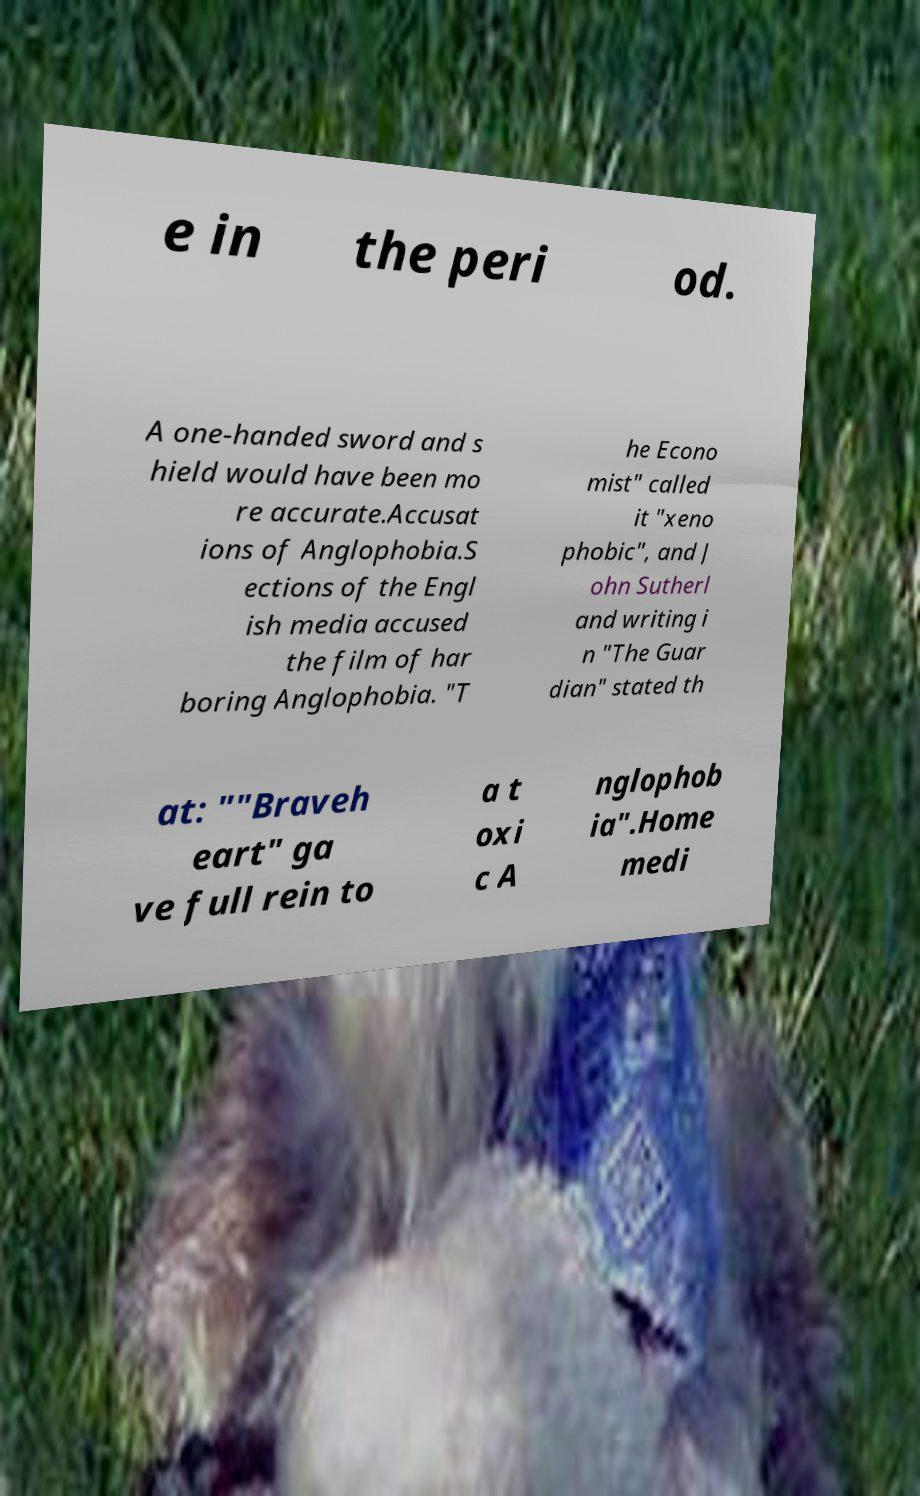Can you read and provide the text displayed in the image?This photo seems to have some interesting text. Can you extract and type it out for me? e in the peri od. A one-handed sword and s hield would have been mo re accurate.Accusat ions of Anglophobia.S ections of the Engl ish media accused the film of har boring Anglophobia. "T he Econo mist" called it "xeno phobic", and J ohn Sutherl and writing i n "The Guar dian" stated th at: ""Braveh eart" ga ve full rein to a t oxi c A nglophob ia".Home medi 